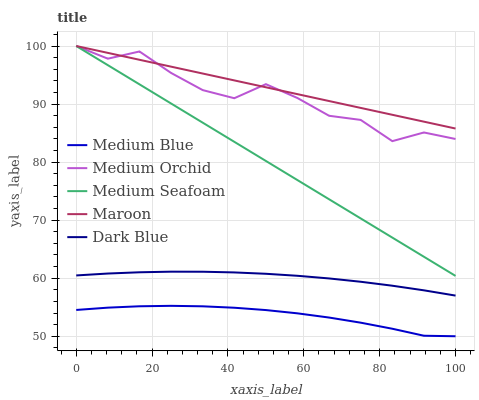Does Medium Blue have the minimum area under the curve?
Answer yes or no. Yes. Does Maroon have the maximum area under the curve?
Answer yes or no. Yes. Does Medium Orchid have the minimum area under the curve?
Answer yes or no. No. Does Medium Orchid have the maximum area under the curve?
Answer yes or no. No. Is Maroon the smoothest?
Answer yes or no. Yes. Is Medium Orchid the roughest?
Answer yes or no. Yes. Is Medium Blue the smoothest?
Answer yes or no. No. Is Medium Blue the roughest?
Answer yes or no. No. Does Medium Blue have the lowest value?
Answer yes or no. Yes. Does Medium Orchid have the lowest value?
Answer yes or no. No. Does Maroon have the highest value?
Answer yes or no. Yes. Does Medium Blue have the highest value?
Answer yes or no. No. Is Dark Blue less than Maroon?
Answer yes or no. Yes. Is Dark Blue greater than Medium Blue?
Answer yes or no. Yes. Does Medium Orchid intersect Medium Seafoam?
Answer yes or no. Yes. Is Medium Orchid less than Medium Seafoam?
Answer yes or no. No. Is Medium Orchid greater than Medium Seafoam?
Answer yes or no. No. Does Dark Blue intersect Maroon?
Answer yes or no. No. 